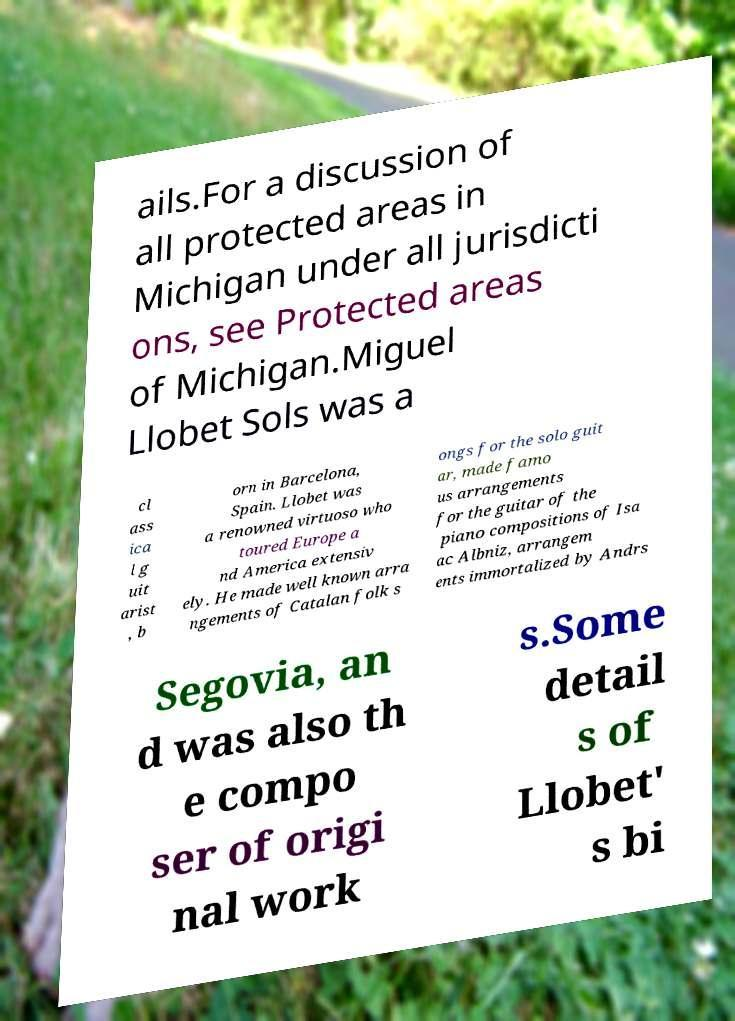Can you read and provide the text displayed in the image?This photo seems to have some interesting text. Can you extract and type it out for me? ails.For a discussion of all protected areas in Michigan under all jurisdicti ons, see Protected areas of Michigan.Miguel Llobet Sols was a cl ass ica l g uit arist , b orn in Barcelona, Spain. Llobet was a renowned virtuoso who toured Europe a nd America extensiv ely. He made well known arra ngements of Catalan folk s ongs for the solo guit ar, made famo us arrangements for the guitar of the piano compositions of Isa ac Albniz, arrangem ents immortalized by Andrs Segovia, an d was also th e compo ser of origi nal work s.Some detail s of Llobet' s bi 